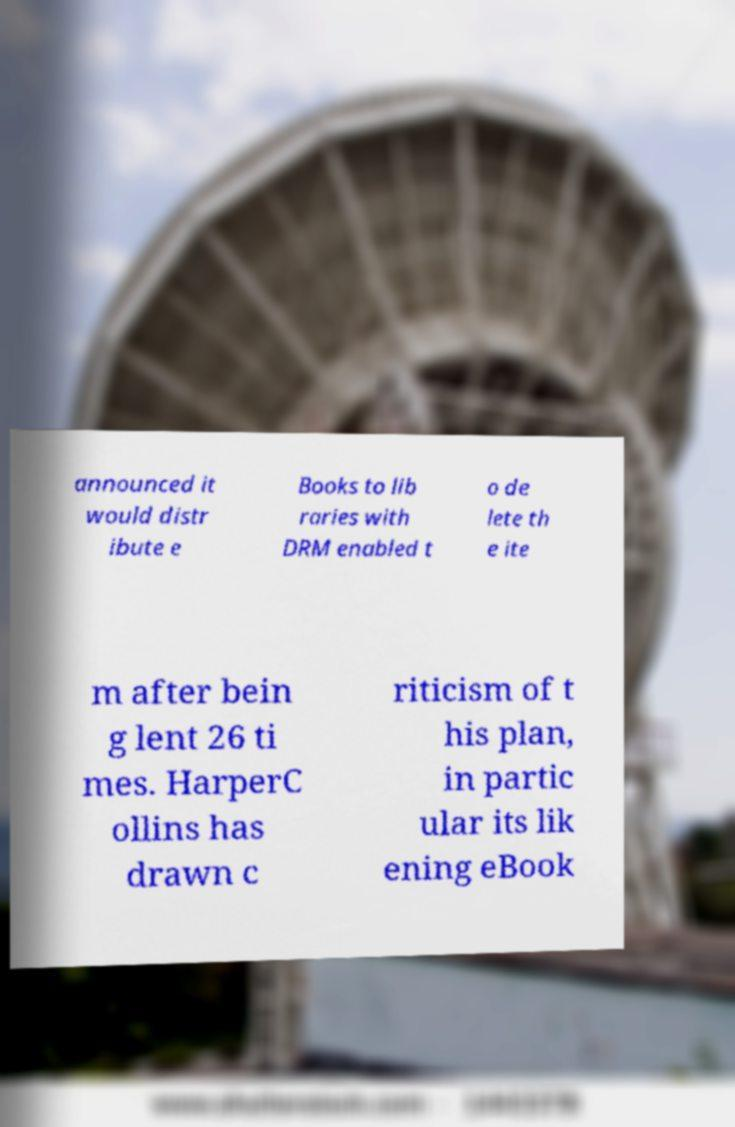Could you extract and type out the text from this image? announced it would distr ibute e Books to lib raries with DRM enabled t o de lete th e ite m after bein g lent 26 ti mes. HarperC ollins has drawn c riticism of t his plan, in partic ular its lik ening eBook 